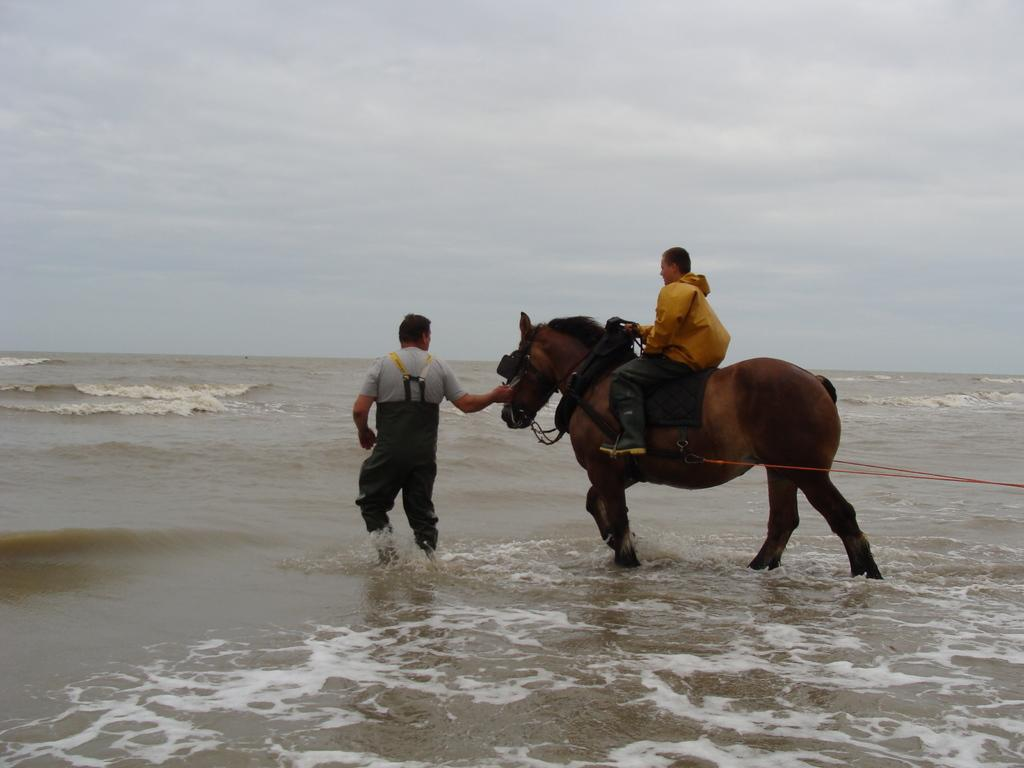What is the man in the image doing? The man is sitting on a horse in the image. What is the other person in the image doing? The other person is standing in the water in the image. What can be seen in the background of the image? The sky is visible in the background of the image. What type of sock is the airport using as an example in the image? There is no airport or sock present in the image; it features a man on a horse and a person standing in the water. 